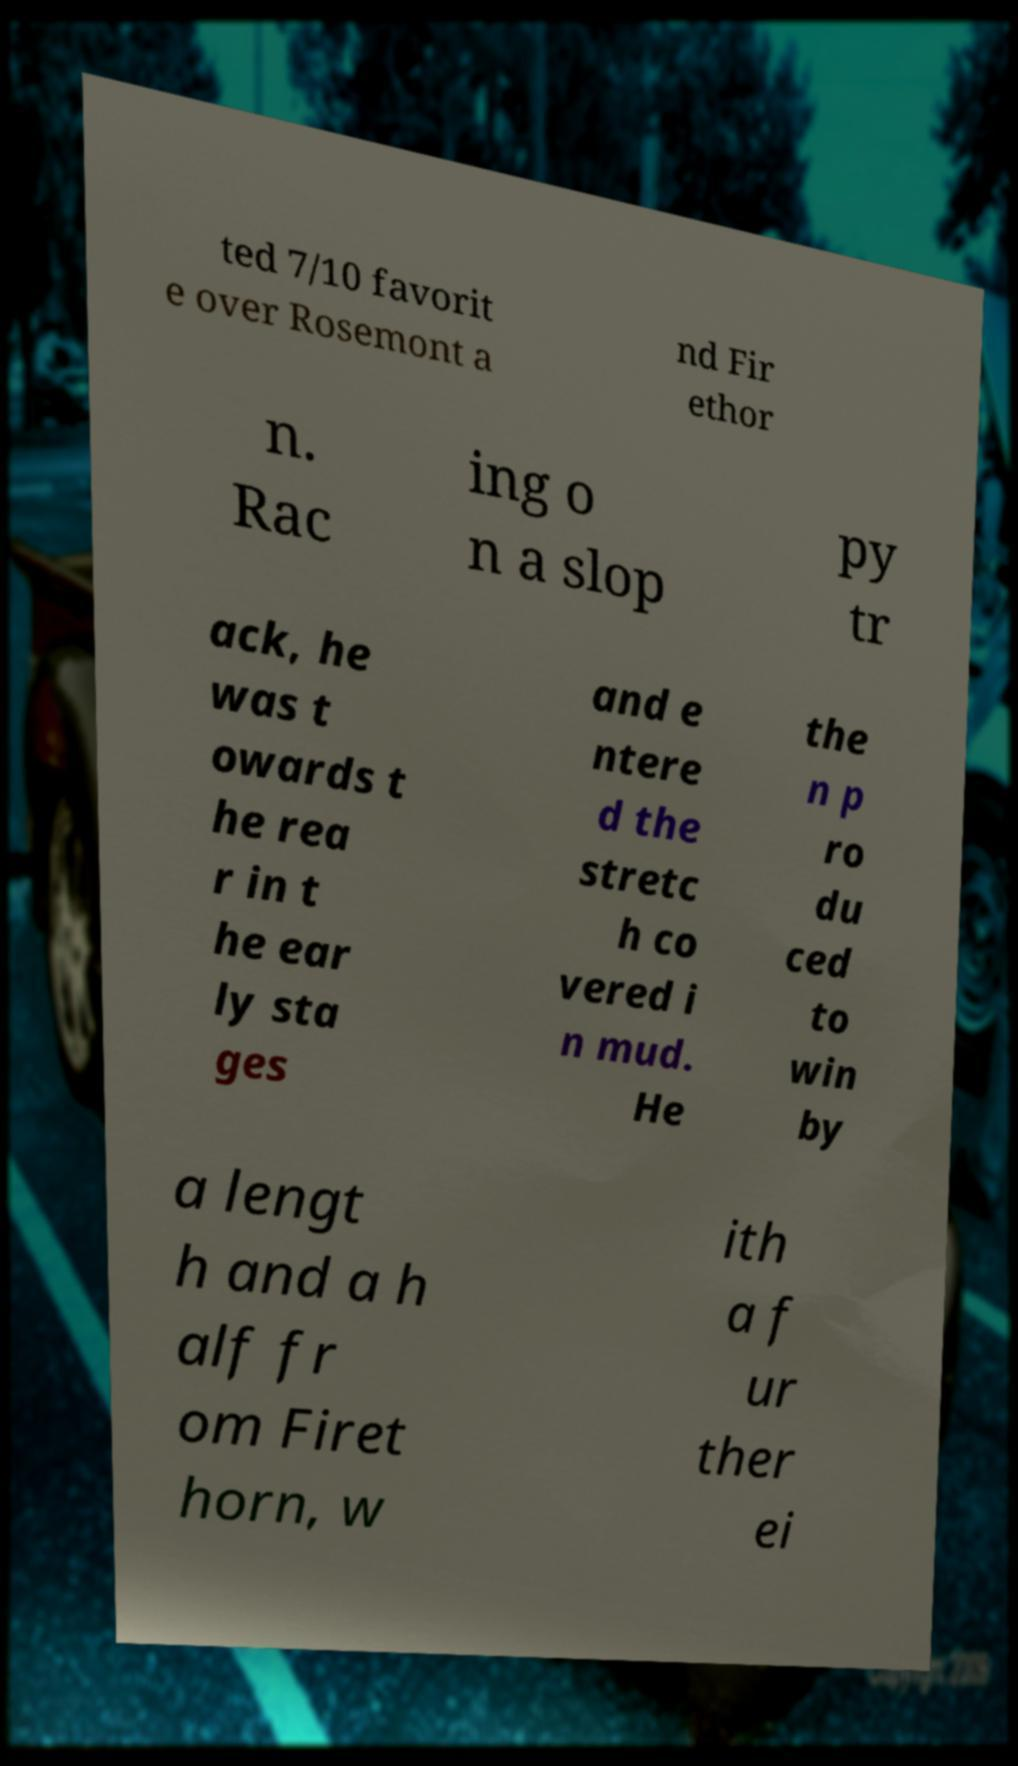There's text embedded in this image that I need extracted. Can you transcribe it verbatim? ted 7/10 favorit e over Rosemont a nd Fir ethor n. Rac ing o n a slop py tr ack, he was t owards t he rea r in t he ear ly sta ges and e ntere d the stretc h co vered i n mud. He the n p ro du ced to win by a lengt h and a h alf fr om Firet horn, w ith a f ur ther ei 